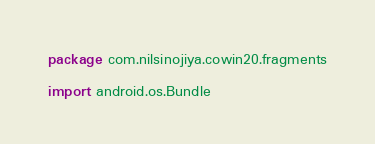<code> <loc_0><loc_0><loc_500><loc_500><_Kotlin_>package com.nilsinojiya.cowin20.fragments

import android.os.Bundle</code> 